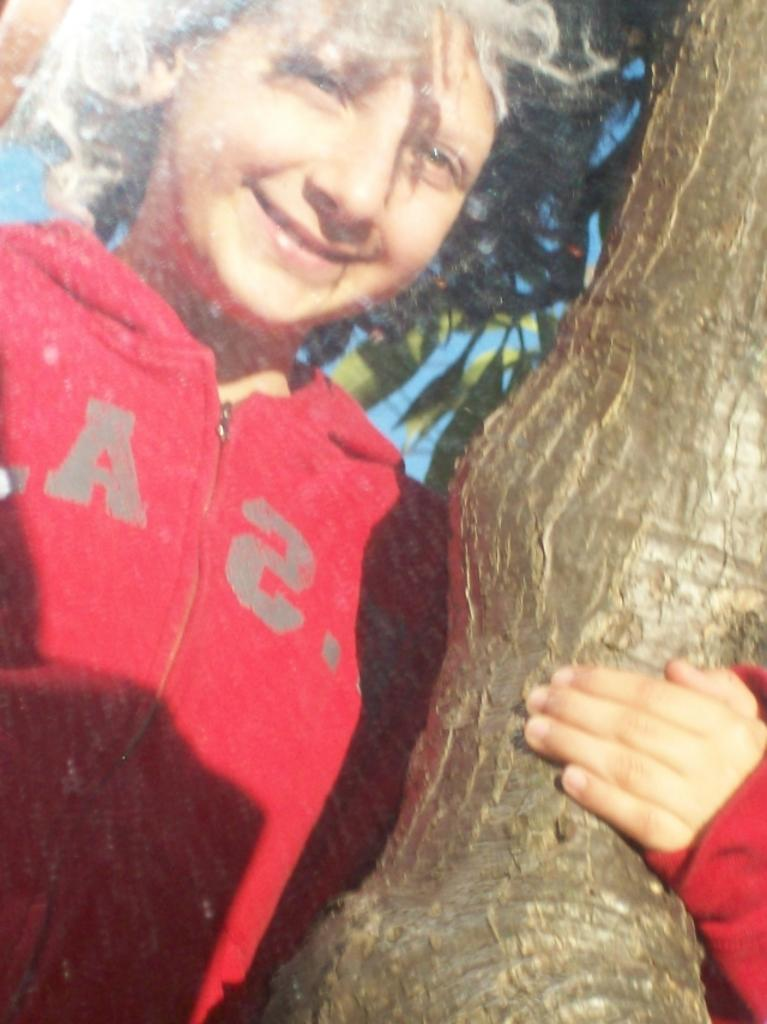Who or what is present in the image? There is a person in the image. What is the person doing in the image? The person is smiling in the image. What can be seen in the background of the image? There is a tree in the background of the image. What type of truck can be seen parked next to the person in the image? There is no truck present in the image; it only features a person and a tree in the background. 